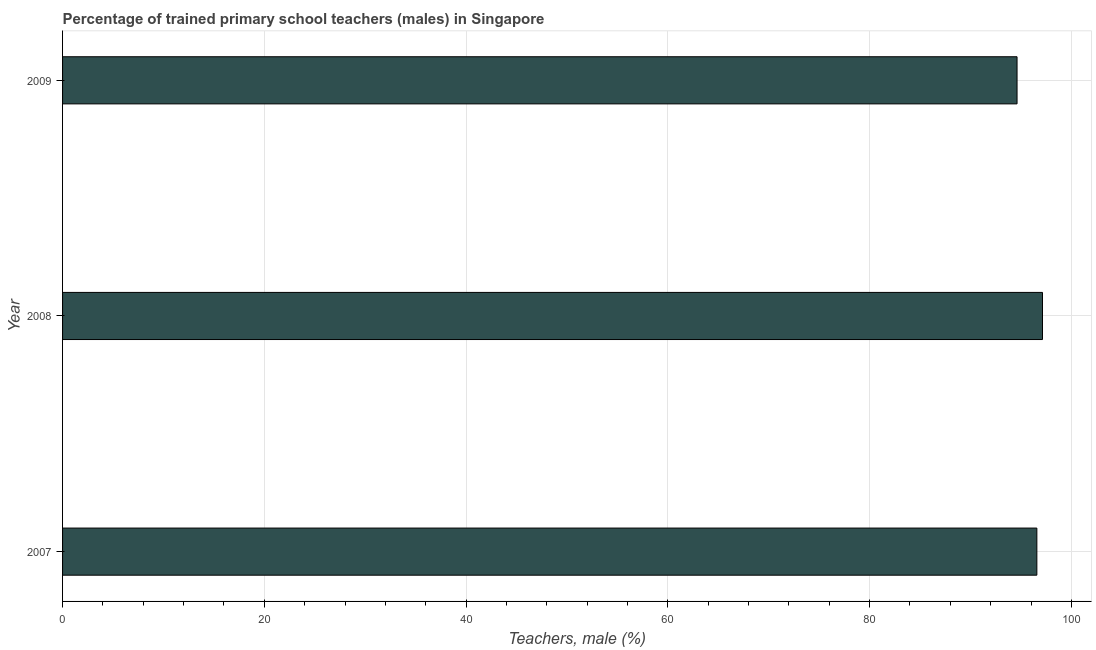Does the graph contain any zero values?
Your answer should be very brief. No. What is the title of the graph?
Make the answer very short. Percentage of trained primary school teachers (males) in Singapore. What is the label or title of the X-axis?
Your response must be concise. Teachers, male (%). What is the label or title of the Y-axis?
Give a very brief answer. Year. What is the percentage of trained male teachers in 2009?
Offer a very short reply. 94.61. Across all years, what is the maximum percentage of trained male teachers?
Give a very brief answer. 97.14. Across all years, what is the minimum percentage of trained male teachers?
Your answer should be compact. 94.61. In which year was the percentage of trained male teachers maximum?
Your response must be concise. 2008. What is the sum of the percentage of trained male teachers?
Provide a short and direct response. 288.33. What is the difference between the percentage of trained male teachers in 2007 and 2008?
Your answer should be compact. -0.56. What is the average percentage of trained male teachers per year?
Your answer should be very brief. 96.11. What is the median percentage of trained male teachers?
Provide a succinct answer. 96.58. Is the percentage of trained male teachers in 2008 less than that in 2009?
Make the answer very short. No. What is the difference between the highest and the second highest percentage of trained male teachers?
Keep it short and to the point. 0.56. What is the difference between the highest and the lowest percentage of trained male teachers?
Keep it short and to the point. 2.52. In how many years, is the percentage of trained male teachers greater than the average percentage of trained male teachers taken over all years?
Provide a succinct answer. 2. How many bars are there?
Provide a short and direct response. 3. Are all the bars in the graph horizontal?
Make the answer very short. Yes. What is the Teachers, male (%) in 2007?
Provide a succinct answer. 96.58. What is the Teachers, male (%) of 2008?
Provide a short and direct response. 97.14. What is the Teachers, male (%) of 2009?
Offer a terse response. 94.61. What is the difference between the Teachers, male (%) in 2007 and 2008?
Provide a short and direct response. -0.56. What is the difference between the Teachers, male (%) in 2007 and 2009?
Keep it short and to the point. 1.96. What is the difference between the Teachers, male (%) in 2008 and 2009?
Your answer should be very brief. 2.52. What is the ratio of the Teachers, male (%) in 2008 to that in 2009?
Give a very brief answer. 1.03. 